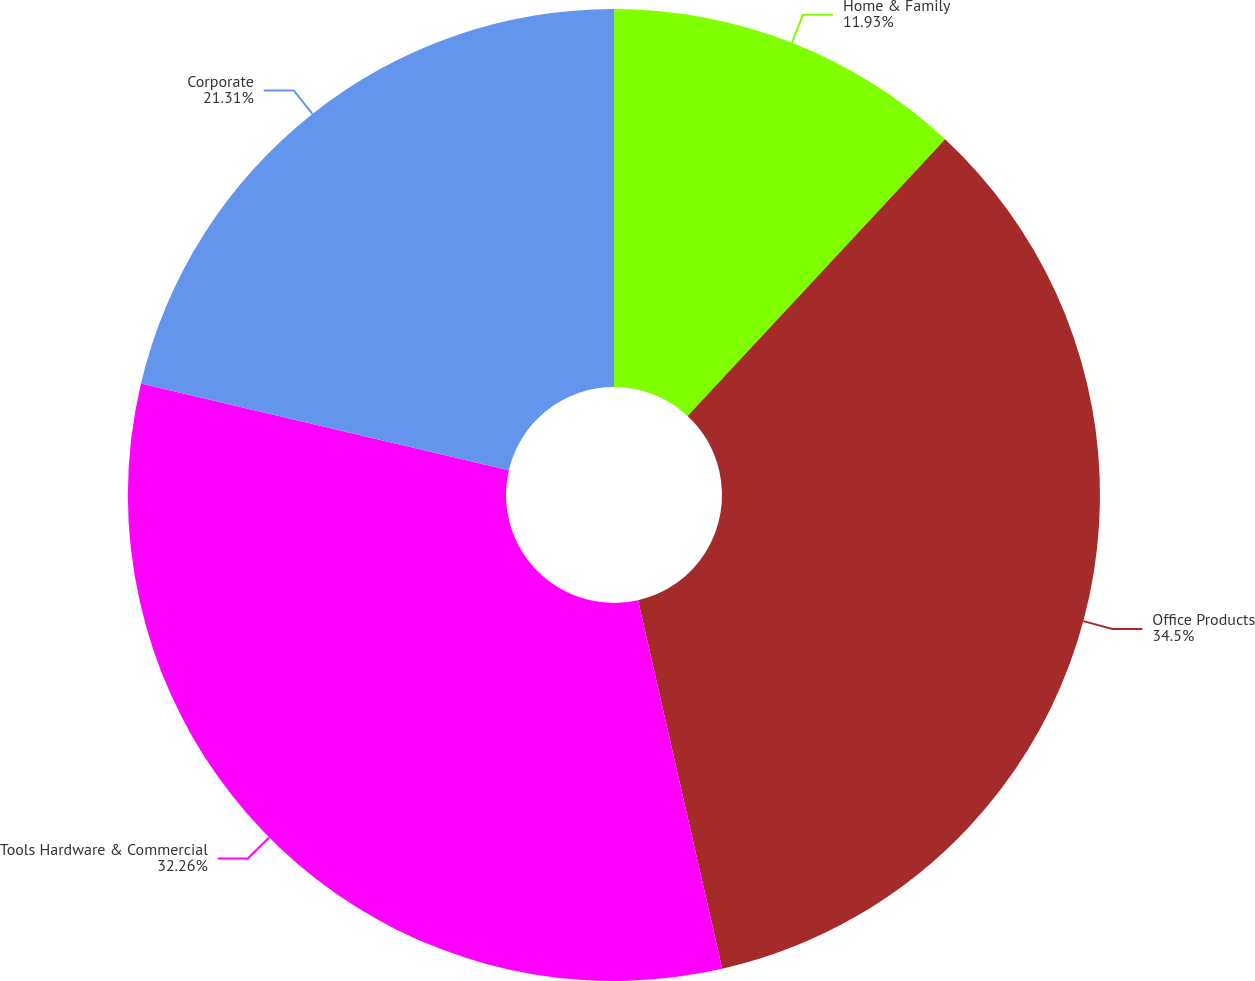Convert chart. <chart><loc_0><loc_0><loc_500><loc_500><pie_chart><fcel>Home & Family<fcel>Office Products<fcel>Tools Hardware & Commercial<fcel>Corporate<nl><fcel>11.93%<fcel>34.49%<fcel>32.26%<fcel>21.31%<nl></chart> 